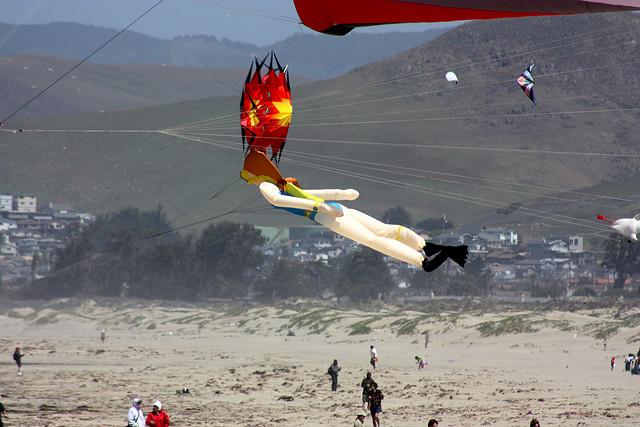Create a fictional scenario involving the prominent humanoid kite in the center. The humanoid kite, named 'Sky Guardian,' was no ordinary kite. It was believed to have been crafted by a mysterious kite-maker who infused it with a touch of magic. On this breezy afternoon, as it soared high above the beach, Sky Guardian surveyed the scene with a sense of purpose. Its fiery colors represented the spirit of the sun, and its humanoid shape was a symbol of protection. The townspeople had long been hearing tales of the kite's magical ability to ward off evil spirits and bring good fortune to those beneath its shadow. Today, a young boy named Timmy held its string, having won it in a local contest. Little did he know, the kite chose its flyer, and by selecting Timmy, Sky Guardian recognized a brave heart. As the winds picked up, Sky Guardian fluttered with a newfound energy, casting a protective aura over the beach. The townspeople felt a serene calm, knowing that as long as Sky Guardian flew high, their town would remain safe and prosperous. 